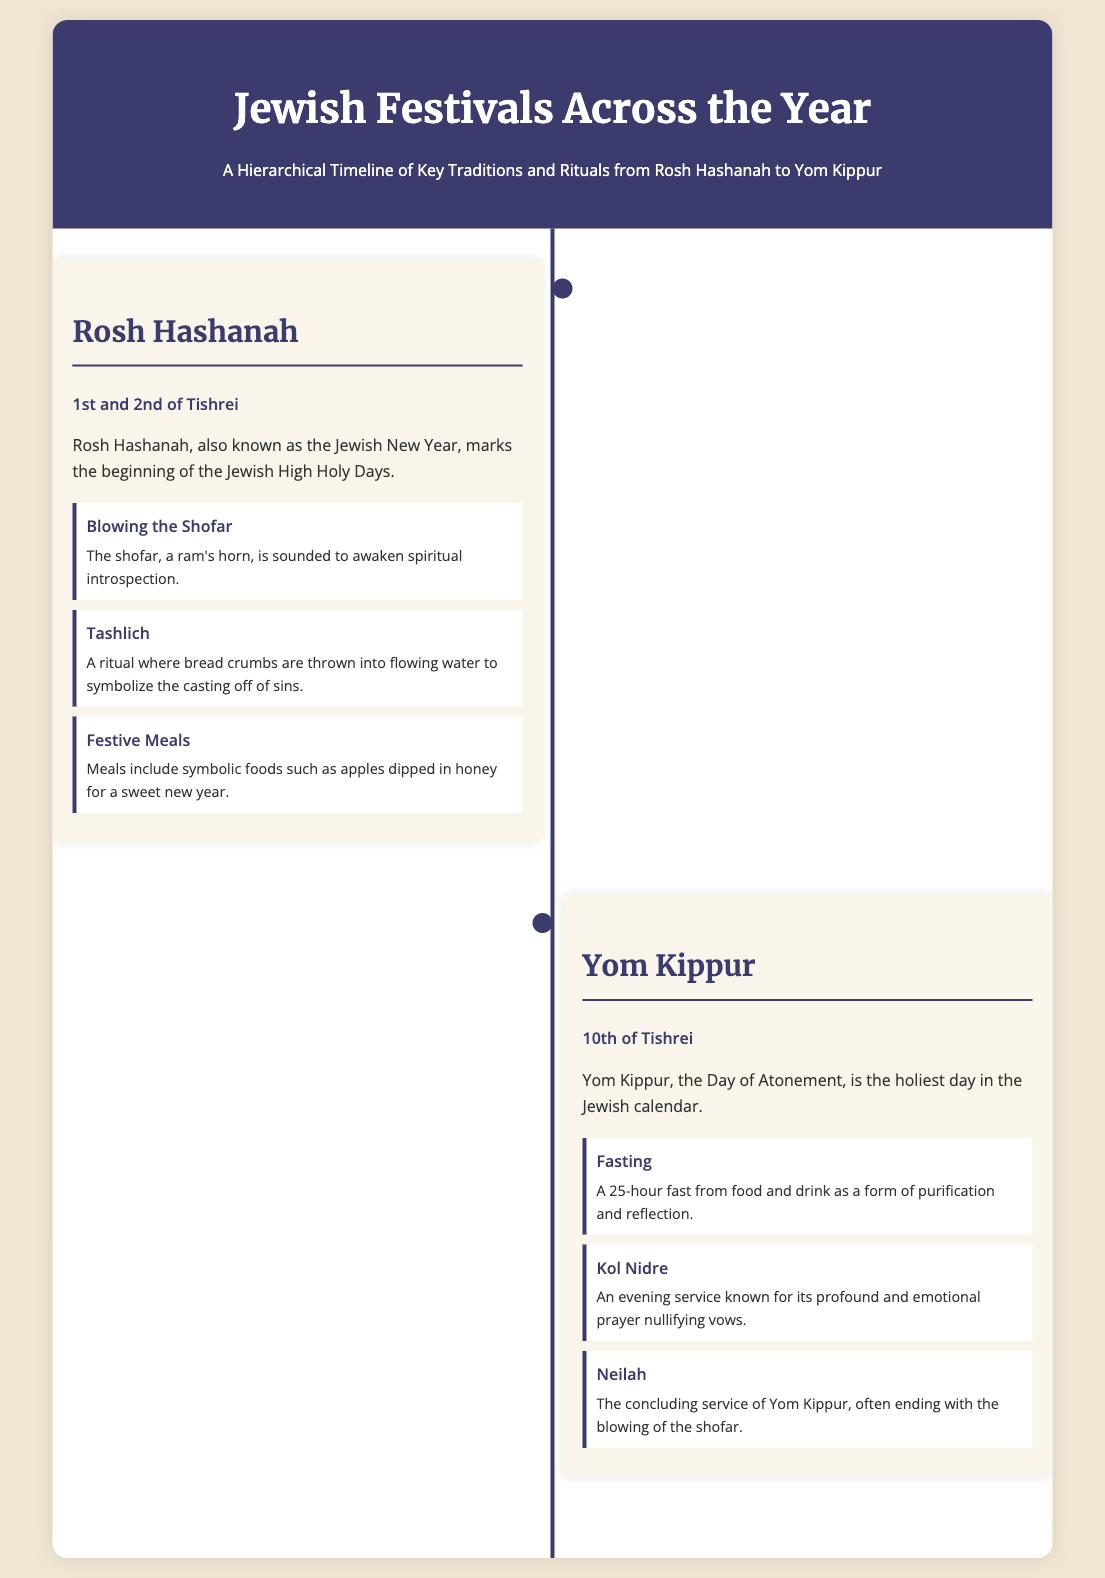What is the Jewish New Year called? The document states that Rosh Hashanah is known as the Jewish New Year.
Answer: Rosh Hashanah When is Rosh Hashanah observed? The document specifies that Rosh Hashanah is observed on the 1st and 2nd of Tishrei.
Answer: 1st and 2nd of Tishrei What ritual involves throwing bread crumbs into water? The document mentions Tashlich as the ritual where bread crumbs are thrown into flowing water.
Answer: Tashlich What is the holiest day in the Jewish calendar? According to the document, Yom Kippur is noted as the holiest day in the Jewish calendar.
Answer: Yom Kippur How long is the fast during Yom Kippur? The document indicates that the fast during Yom Kippur lasts for 25 hours.
Answer: 25 hours Which service is known for nullifying vows? The document highlights the Kol Nidre service as known for its profound prayer to nullify vows.
Answer: Kol Nidre What is the concluding service of Yom Kippur called? The document mentions that the concluding service of Yom Kippur is called Neilah.
Answer: Neilah What type of document is this? The document presents a hierarchical timeline of Jewish festivals and traditions.
Answer: Hierarchical timeline 